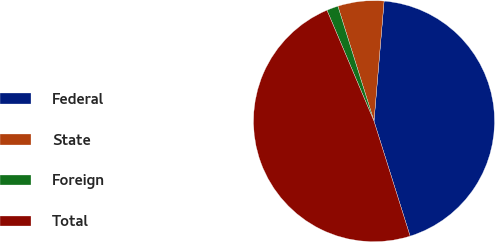<chart> <loc_0><loc_0><loc_500><loc_500><pie_chart><fcel>Federal<fcel>State<fcel>Foreign<fcel>Total<nl><fcel>43.82%<fcel>6.18%<fcel>1.54%<fcel>48.46%<nl></chart> 